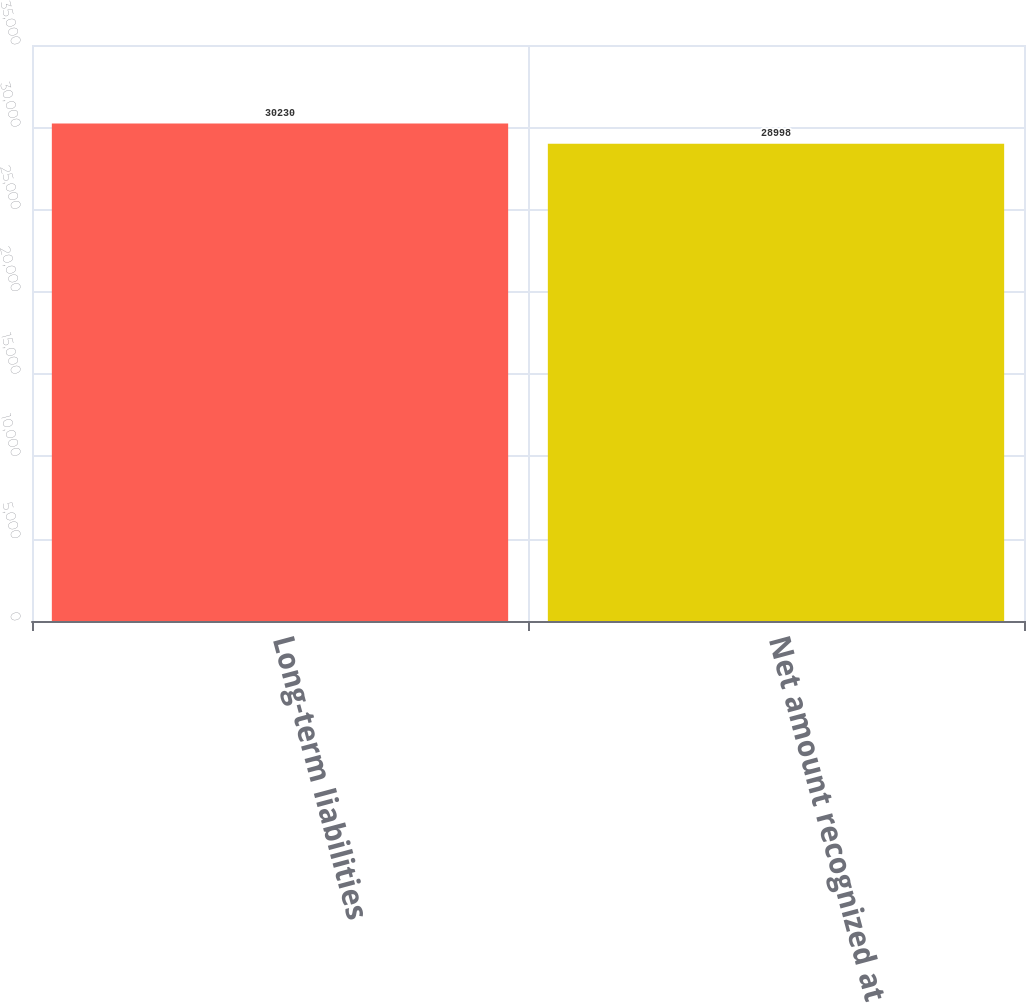<chart> <loc_0><loc_0><loc_500><loc_500><bar_chart><fcel>Long-term liabilities<fcel>Net amount recognized at<nl><fcel>30230<fcel>28998<nl></chart> 